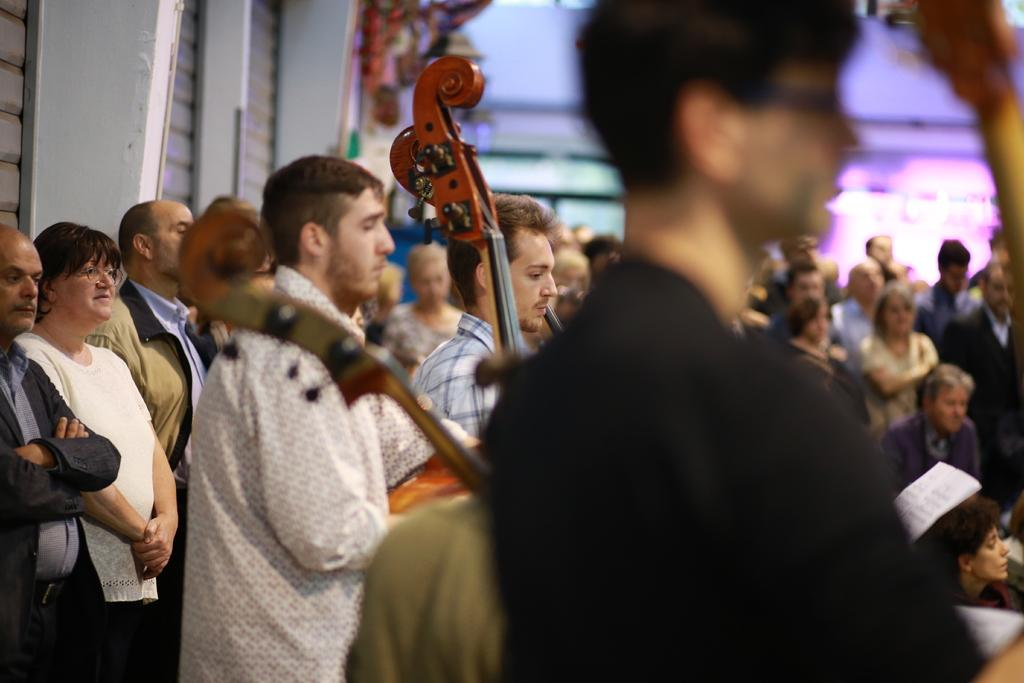How many people are in the image? There is a group of people in the image. What are two people in the group doing? Two people in the group are holding musical instruments in the image. What religion is being practiced by the people in the image? There is no indication of any religious practice in the image. What type of metal is visible in the image? There is no metal visible in the image. 